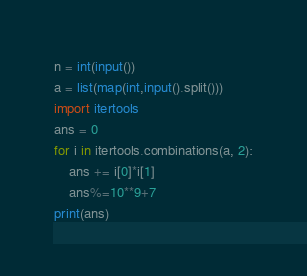Convert code to text. <code><loc_0><loc_0><loc_500><loc_500><_Python_>n = int(input())
a = list(map(int,input().split()))
import itertools
ans = 0
for i in itertools.combinations(a, 2):
    ans += i[0]*i[1]
    ans%=10**9+7
print(ans)</code> 